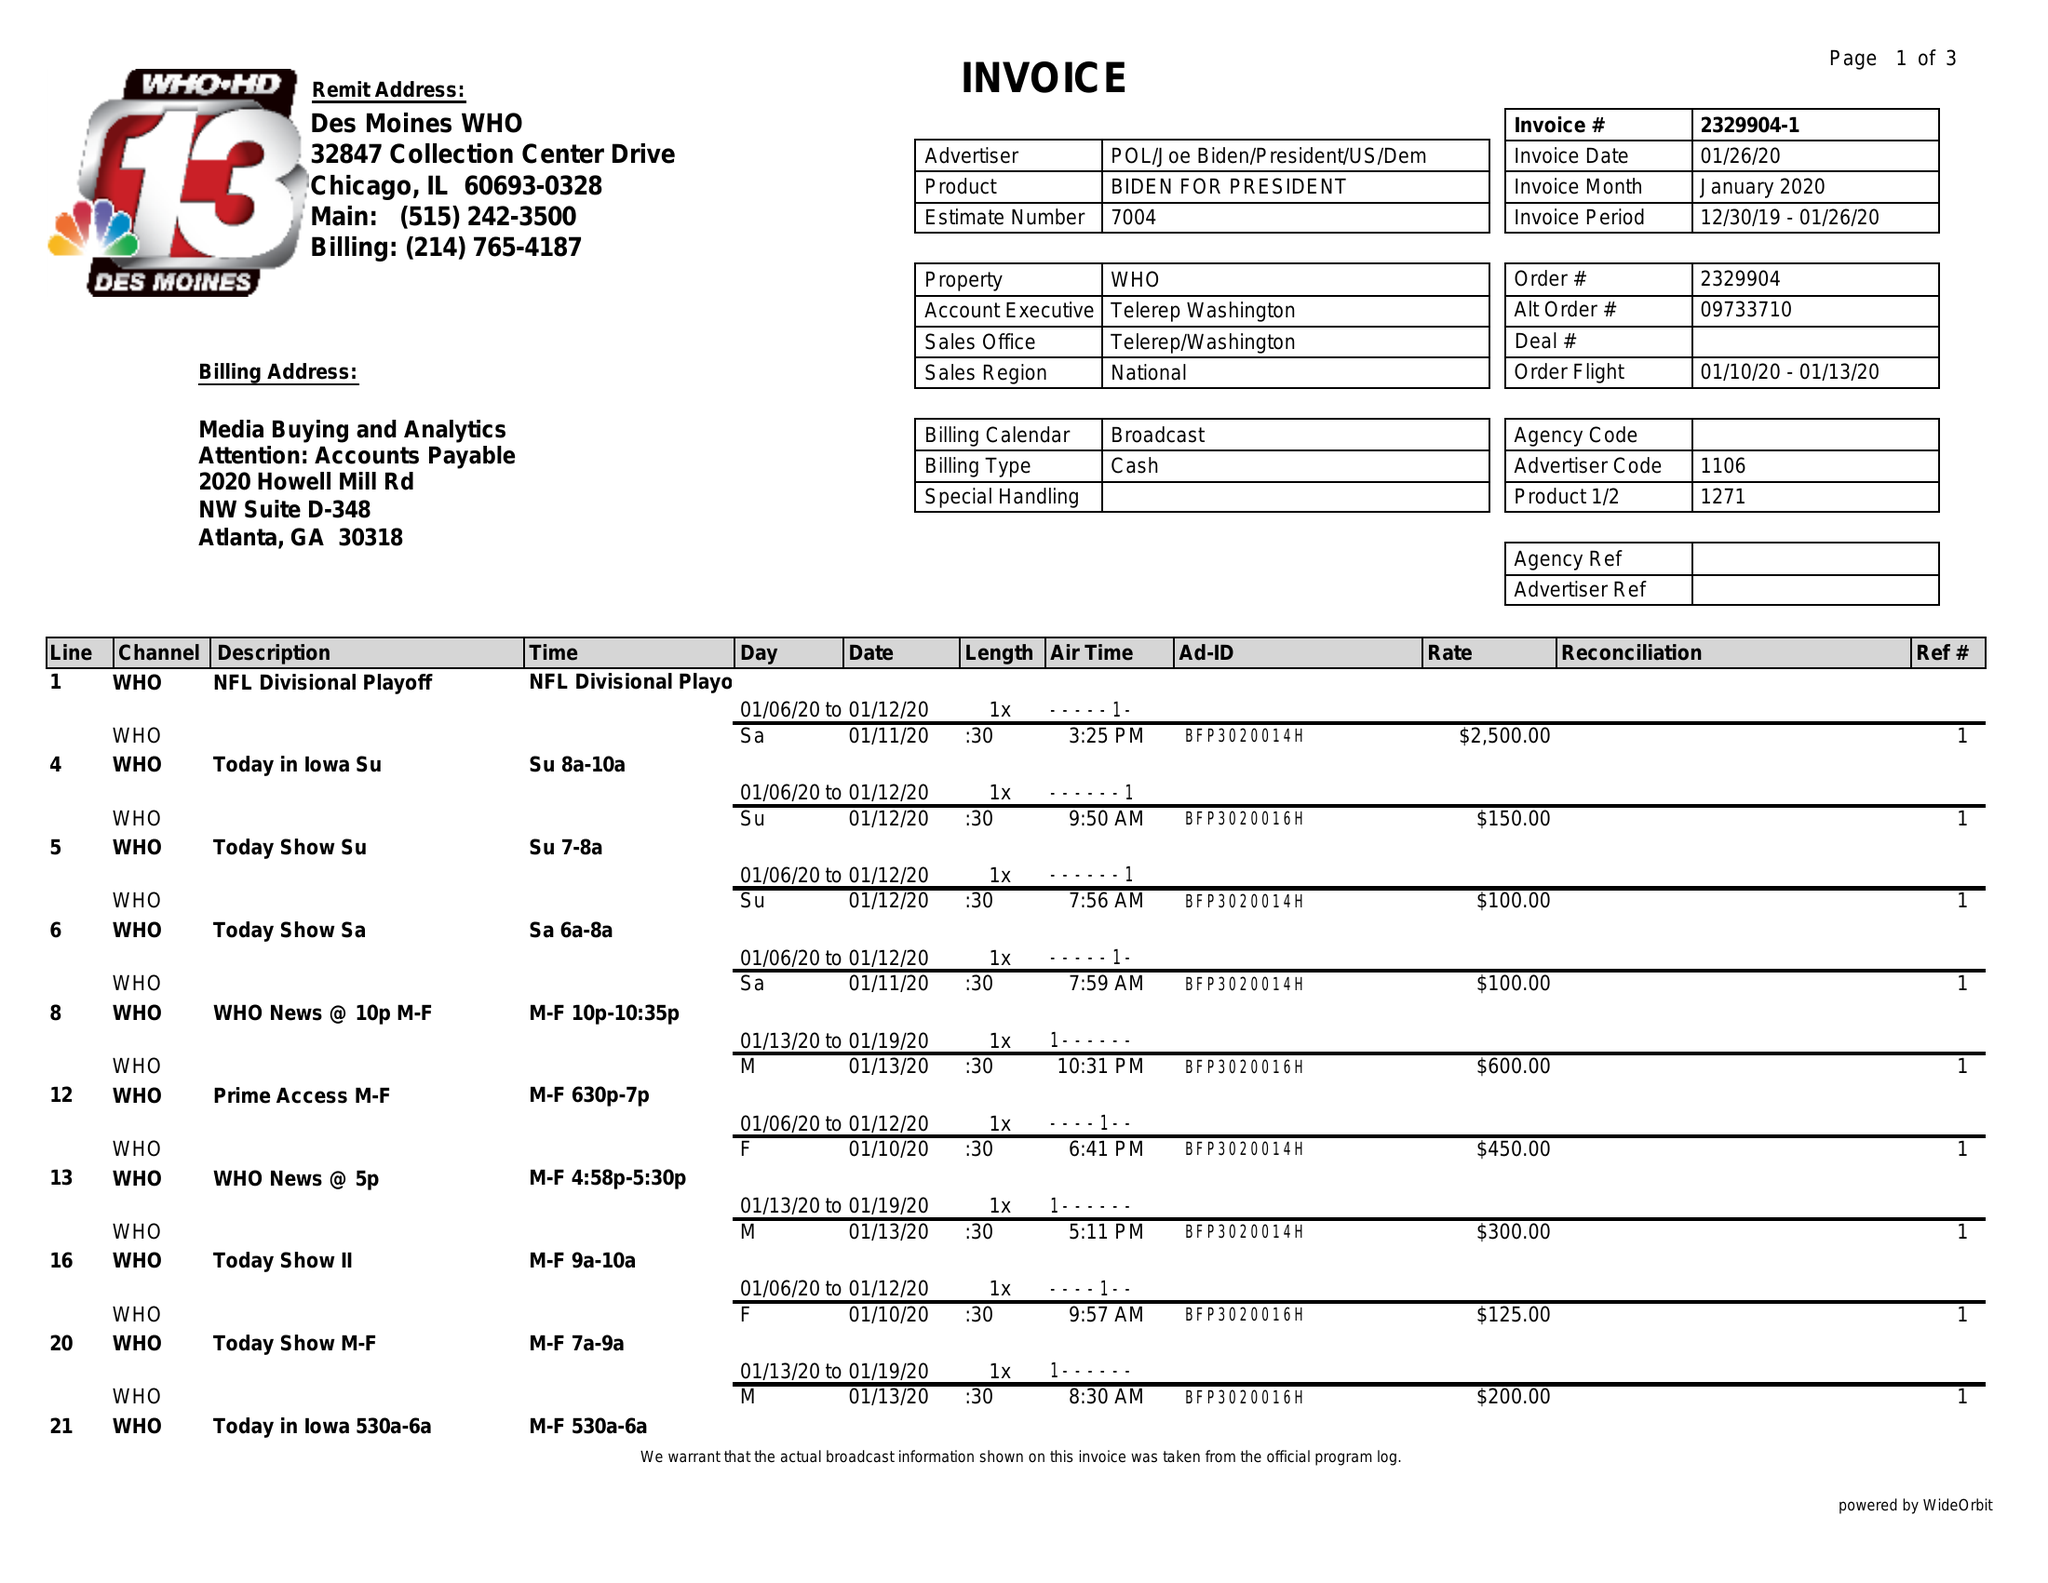What is the value for the flight_to?
Answer the question using a single word or phrase. 01/13/20 